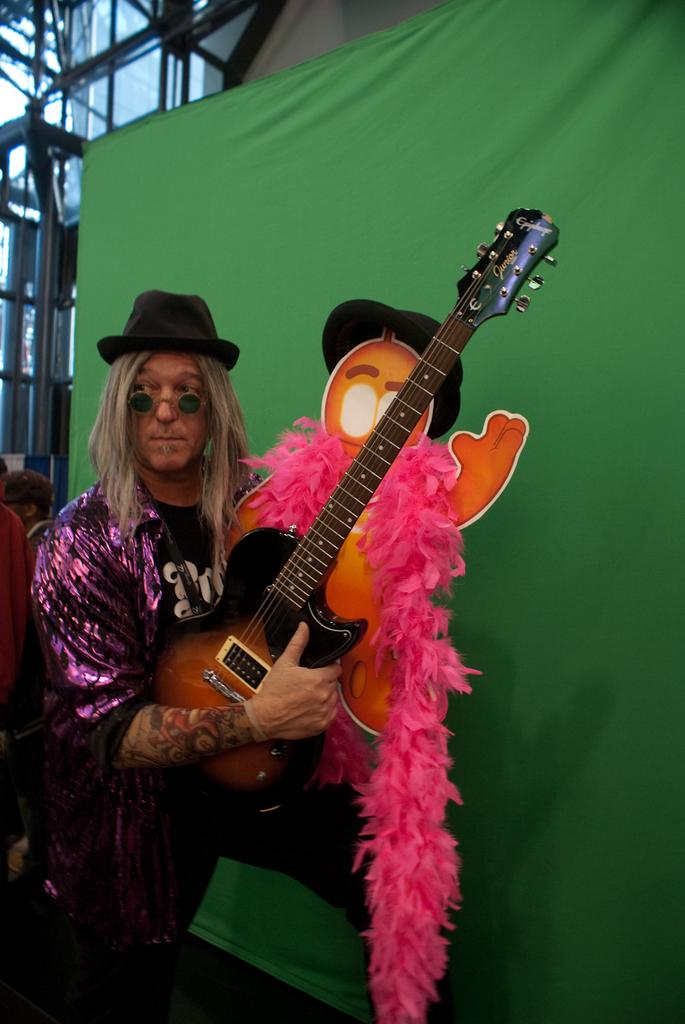What is the person in the image doing? The person is standing in the image and holding a guitar. What object is the person holding in the image? The person is holding a guitar. What can be seen in the background of the image? There is a banner visible in the background of the image. How does the person in the image solve the riddle presented on the banner? There is no riddle present on the banner in the image, so it cannot be solved by the person. 